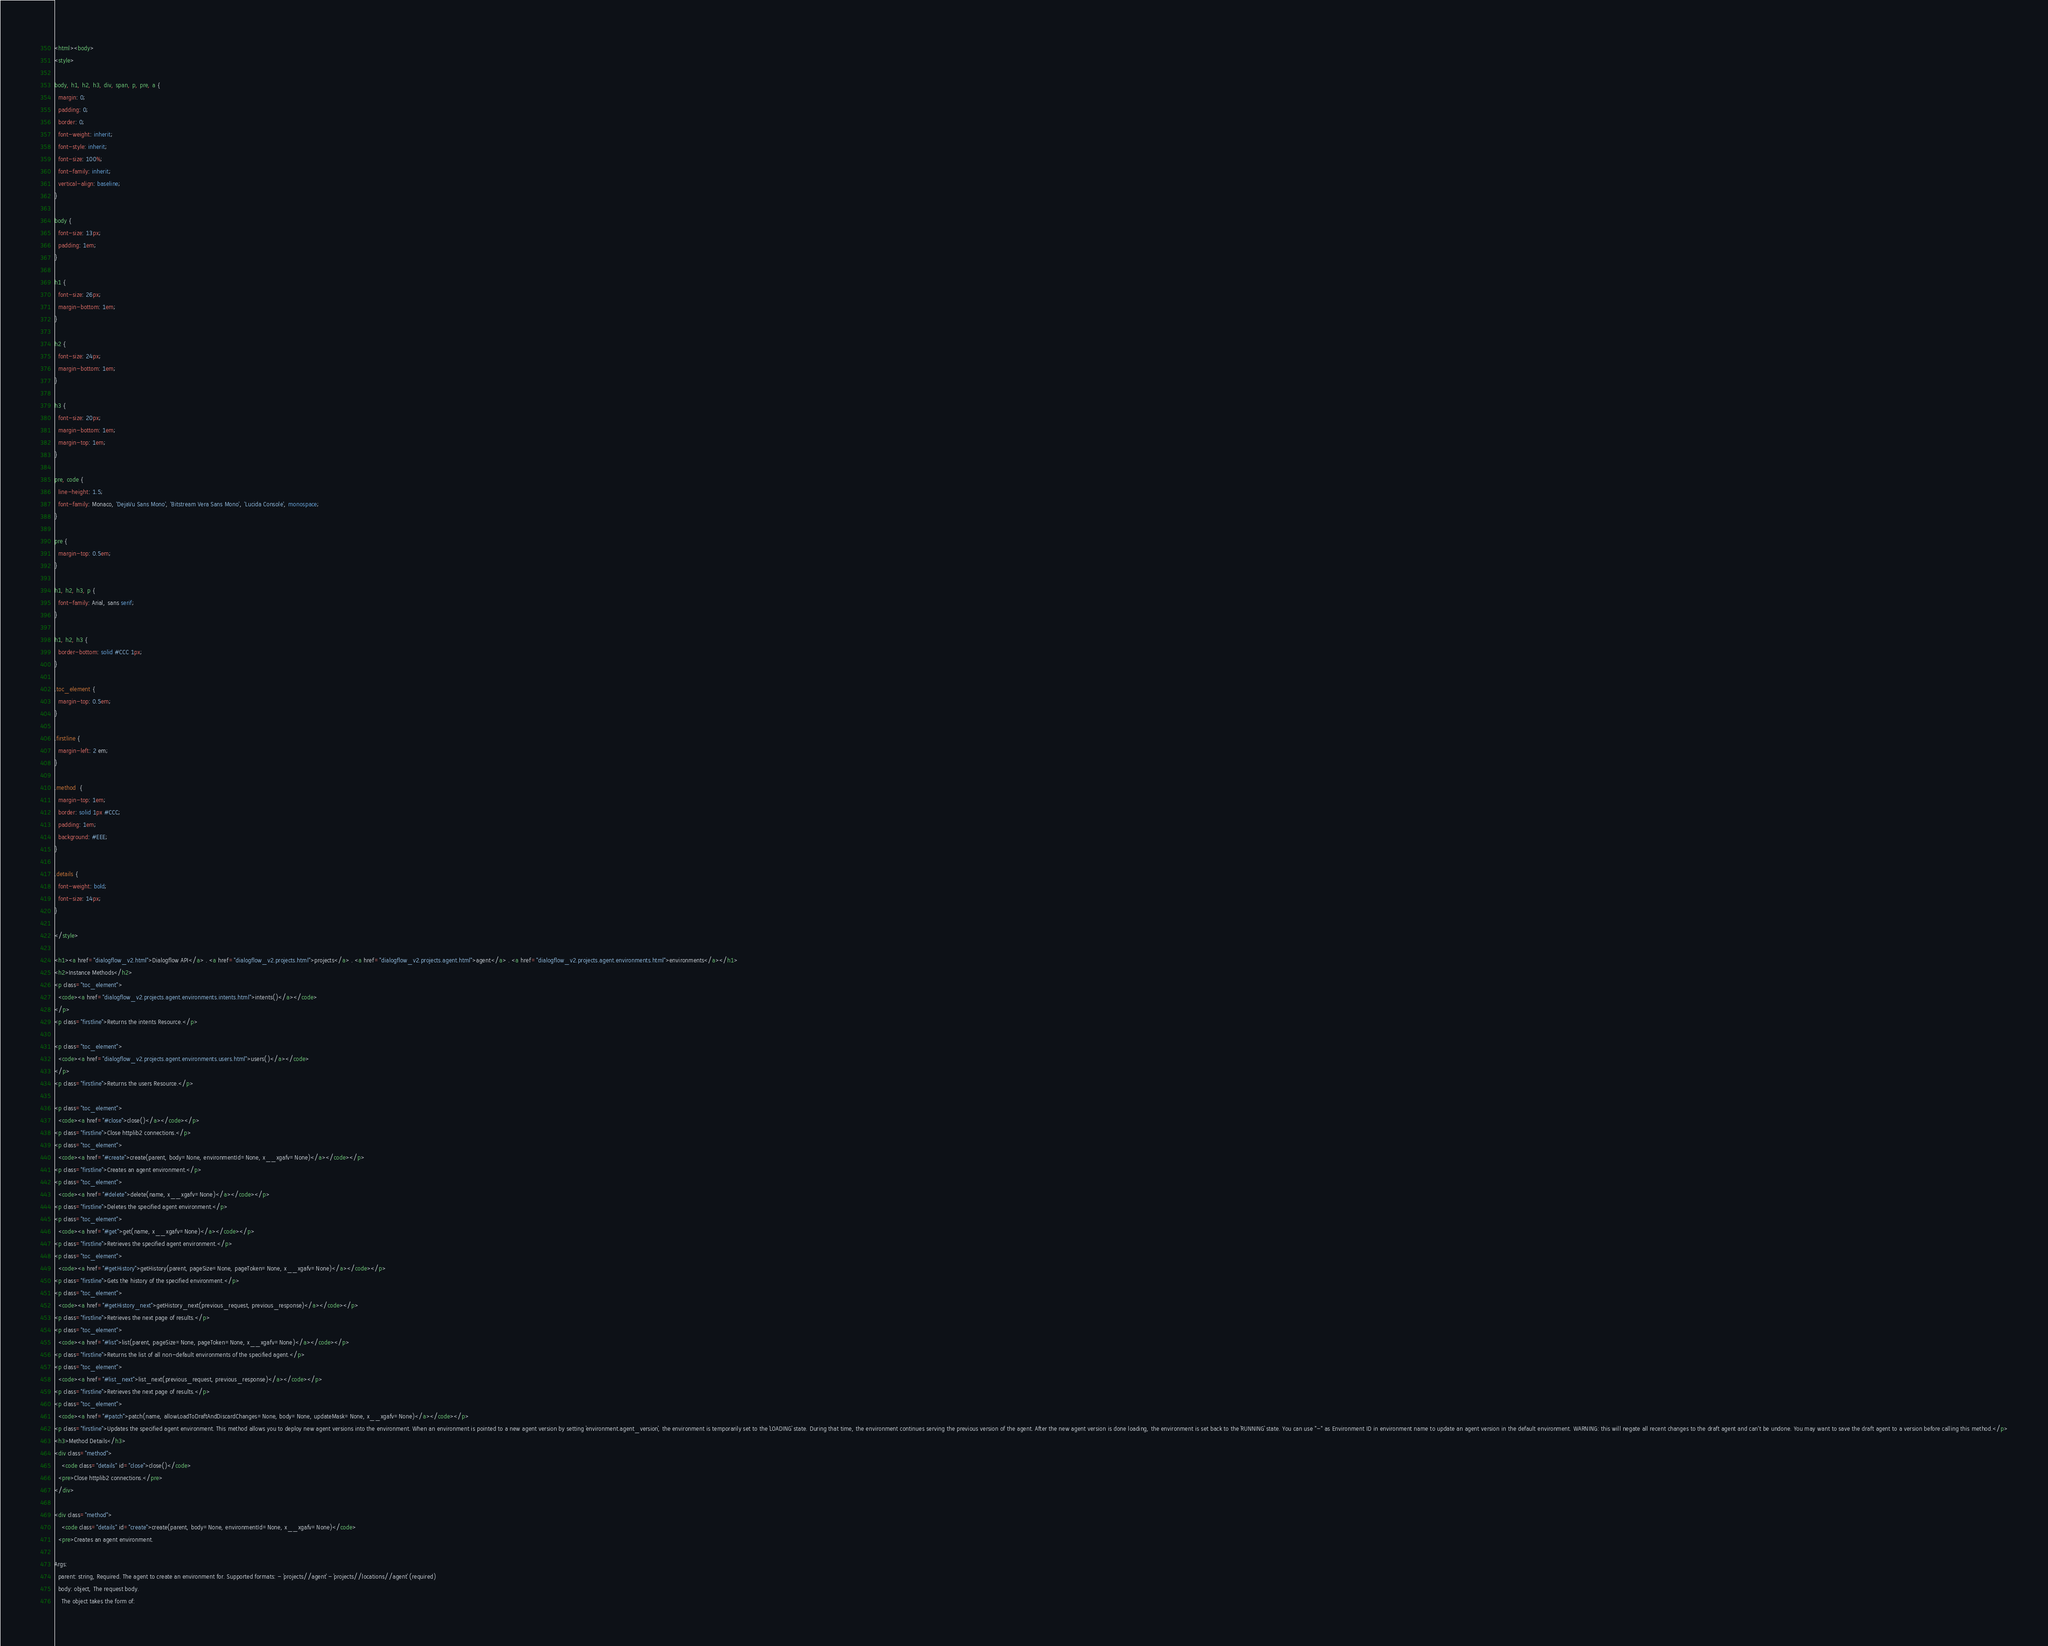Convert code to text. <code><loc_0><loc_0><loc_500><loc_500><_HTML_><html><body>
<style>

body, h1, h2, h3, div, span, p, pre, a {
  margin: 0;
  padding: 0;
  border: 0;
  font-weight: inherit;
  font-style: inherit;
  font-size: 100%;
  font-family: inherit;
  vertical-align: baseline;
}

body {
  font-size: 13px;
  padding: 1em;
}

h1 {
  font-size: 26px;
  margin-bottom: 1em;
}

h2 {
  font-size: 24px;
  margin-bottom: 1em;
}

h3 {
  font-size: 20px;
  margin-bottom: 1em;
  margin-top: 1em;
}

pre, code {
  line-height: 1.5;
  font-family: Monaco, 'DejaVu Sans Mono', 'Bitstream Vera Sans Mono', 'Lucida Console', monospace;
}

pre {
  margin-top: 0.5em;
}

h1, h2, h3, p {
  font-family: Arial, sans serif;
}

h1, h2, h3 {
  border-bottom: solid #CCC 1px;
}

.toc_element {
  margin-top: 0.5em;
}

.firstline {
  margin-left: 2 em;
}

.method  {
  margin-top: 1em;
  border: solid 1px #CCC;
  padding: 1em;
  background: #EEE;
}

.details {
  font-weight: bold;
  font-size: 14px;
}

</style>

<h1><a href="dialogflow_v2.html">Dialogflow API</a> . <a href="dialogflow_v2.projects.html">projects</a> . <a href="dialogflow_v2.projects.agent.html">agent</a> . <a href="dialogflow_v2.projects.agent.environments.html">environments</a></h1>
<h2>Instance Methods</h2>
<p class="toc_element">
  <code><a href="dialogflow_v2.projects.agent.environments.intents.html">intents()</a></code>
</p>
<p class="firstline">Returns the intents Resource.</p>

<p class="toc_element">
  <code><a href="dialogflow_v2.projects.agent.environments.users.html">users()</a></code>
</p>
<p class="firstline">Returns the users Resource.</p>

<p class="toc_element">
  <code><a href="#close">close()</a></code></p>
<p class="firstline">Close httplib2 connections.</p>
<p class="toc_element">
  <code><a href="#create">create(parent, body=None, environmentId=None, x__xgafv=None)</a></code></p>
<p class="firstline">Creates an agent environment.</p>
<p class="toc_element">
  <code><a href="#delete">delete(name, x__xgafv=None)</a></code></p>
<p class="firstline">Deletes the specified agent environment.</p>
<p class="toc_element">
  <code><a href="#get">get(name, x__xgafv=None)</a></code></p>
<p class="firstline">Retrieves the specified agent environment.</p>
<p class="toc_element">
  <code><a href="#getHistory">getHistory(parent, pageSize=None, pageToken=None, x__xgafv=None)</a></code></p>
<p class="firstline">Gets the history of the specified environment.</p>
<p class="toc_element">
  <code><a href="#getHistory_next">getHistory_next(previous_request, previous_response)</a></code></p>
<p class="firstline">Retrieves the next page of results.</p>
<p class="toc_element">
  <code><a href="#list">list(parent, pageSize=None, pageToken=None, x__xgafv=None)</a></code></p>
<p class="firstline">Returns the list of all non-default environments of the specified agent.</p>
<p class="toc_element">
  <code><a href="#list_next">list_next(previous_request, previous_response)</a></code></p>
<p class="firstline">Retrieves the next page of results.</p>
<p class="toc_element">
  <code><a href="#patch">patch(name, allowLoadToDraftAndDiscardChanges=None, body=None, updateMask=None, x__xgafv=None)</a></code></p>
<p class="firstline">Updates the specified agent environment. This method allows you to deploy new agent versions into the environment. When an environment is pointed to a new agent version by setting `environment.agent_version`, the environment is temporarily set to the `LOADING` state. During that time, the environment continues serving the previous version of the agent. After the new agent version is done loading, the environment is set back to the `RUNNING` state. You can use "-" as Environment ID in environment name to update an agent version in the default environment. WARNING: this will negate all recent changes to the draft agent and can't be undone. You may want to save the draft agent to a version before calling this method.</p>
<h3>Method Details</h3>
<div class="method">
    <code class="details" id="close">close()</code>
  <pre>Close httplib2 connections.</pre>
</div>

<div class="method">
    <code class="details" id="create">create(parent, body=None, environmentId=None, x__xgafv=None)</code>
  <pre>Creates an agent environment.

Args:
  parent: string, Required. The agent to create an environment for. Supported formats: - `projects//agent` - `projects//locations//agent` (required)
  body: object, The request body.
    The object takes the form of:
</code> 